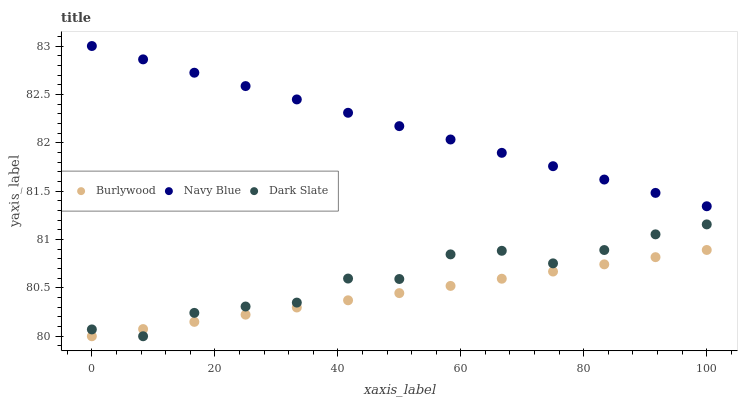Does Burlywood have the minimum area under the curve?
Answer yes or no. Yes. Does Navy Blue have the maximum area under the curve?
Answer yes or no. Yes. Does Dark Slate have the minimum area under the curve?
Answer yes or no. No. Does Dark Slate have the maximum area under the curve?
Answer yes or no. No. Is Burlywood the smoothest?
Answer yes or no. Yes. Is Dark Slate the roughest?
Answer yes or no. Yes. Is Navy Blue the smoothest?
Answer yes or no. No. Is Navy Blue the roughest?
Answer yes or no. No. Does Burlywood have the lowest value?
Answer yes or no. Yes. Does Navy Blue have the lowest value?
Answer yes or no. No. Does Navy Blue have the highest value?
Answer yes or no. Yes. Does Dark Slate have the highest value?
Answer yes or no. No. Is Burlywood less than Navy Blue?
Answer yes or no. Yes. Is Navy Blue greater than Burlywood?
Answer yes or no. Yes. Does Dark Slate intersect Burlywood?
Answer yes or no. Yes. Is Dark Slate less than Burlywood?
Answer yes or no. No. Is Dark Slate greater than Burlywood?
Answer yes or no. No. Does Burlywood intersect Navy Blue?
Answer yes or no. No. 